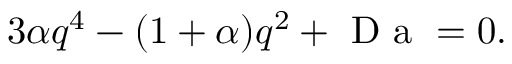Convert formula to latex. <formula><loc_0><loc_0><loc_500><loc_500>3 \alpha q ^ { 4 } - ( 1 + \alpha ) q ^ { 2 } + D a = 0 .</formula> 